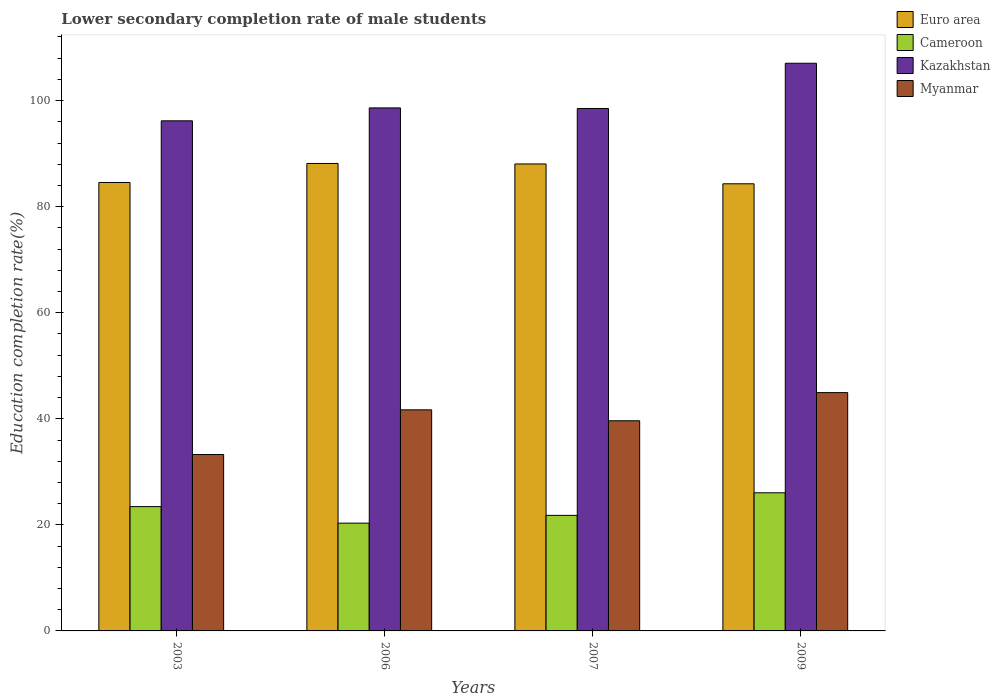How many groups of bars are there?
Provide a succinct answer. 4. Are the number of bars on each tick of the X-axis equal?
Keep it short and to the point. Yes. How many bars are there on the 1st tick from the right?
Ensure brevity in your answer.  4. What is the label of the 4th group of bars from the left?
Your answer should be very brief. 2009. In how many cases, is the number of bars for a given year not equal to the number of legend labels?
Make the answer very short. 0. What is the lower secondary completion rate of male students in Kazakhstan in 2006?
Provide a succinct answer. 98.63. Across all years, what is the maximum lower secondary completion rate of male students in Cameroon?
Provide a short and direct response. 26.05. Across all years, what is the minimum lower secondary completion rate of male students in Cameroon?
Offer a terse response. 20.32. What is the total lower secondary completion rate of male students in Myanmar in the graph?
Make the answer very short. 159.52. What is the difference between the lower secondary completion rate of male students in Myanmar in 2003 and that in 2006?
Your answer should be very brief. -8.43. What is the difference between the lower secondary completion rate of male students in Euro area in 2007 and the lower secondary completion rate of male students in Myanmar in 2003?
Your answer should be very brief. 54.79. What is the average lower secondary completion rate of male students in Myanmar per year?
Offer a terse response. 39.88. In the year 2009, what is the difference between the lower secondary completion rate of male students in Euro area and lower secondary completion rate of male students in Cameroon?
Provide a succinct answer. 58.27. What is the ratio of the lower secondary completion rate of male students in Euro area in 2003 to that in 2009?
Your answer should be very brief. 1. What is the difference between the highest and the second highest lower secondary completion rate of male students in Euro area?
Your response must be concise. 0.09. What is the difference between the highest and the lowest lower secondary completion rate of male students in Euro area?
Provide a short and direct response. 3.83. Is the sum of the lower secondary completion rate of male students in Kazakhstan in 2003 and 2009 greater than the maximum lower secondary completion rate of male students in Euro area across all years?
Your answer should be very brief. Yes. What does the 1st bar from the right in 2007 represents?
Keep it short and to the point. Myanmar. Is it the case that in every year, the sum of the lower secondary completion rate of male students in Kazakhstan and lower secondary completion rate of male students in Cameroon is greater than the lower secondary completion rate of male students in Myanmar?
Your answer should be compact. Yes. How many bars are there?
Your answer should be very brief. 16. How many years are there in the graph?
Your answer should be compact. 4. What is the difference between two consecutive major ticks on the Y-axis?
Provide a short and direct response. 20. Does the graph contain any zero values?
Your response must be concise. No. Does the graph contain grids?
Your answer should be compact. No. How many legend labels are there?
Offer a very short reply. 4. What is the title of the graph?
Ensure brevity in your answer.  Lower secondary completion rate of male students. Does "Tanzania" appear as one of the legend labels in the graph?
Ensure brevity in your answer.  No. What is the label or title of the X-axis?
Offer a very short reply. Years. What is the label or title of the Y-axis?
Ensure brevity in your answer.  Education completion rate(%). What is the Education completion rate(%) of Euro area in 2003?
Offer a terse response. 84.56. What is the Education completion rate(%) in Cameroon in 2003?
Your answer should be compact. 23.44. What is the Education completion rate(%) of Kazakhstan in 2003?
Offer a very short reply. 96.19. What is the Education completion rate(%) in Myanmar in 2003?
Provide a short and direct response. 33.26. What is the Education completion rate(%) of Euro area in 2006?
Provide a succinct answer. 88.15. What is the Education completion rate(%) of Cameroon in 2006?
Offer a terse response. 20.32. What is the Education completion rate(%) in Kazakhstan in 2006?
Offer a terse response. 98.63. What is the Education completion rate(%) of Myanmar in 2006?
Your answer should be very brief. 41.69. What is the Education completion rate(%) in Euro area in 2007?
Give a very brief answer. 88.06. What is the Education completion rate(%) in Cameroon in 2007?
Provide a short and direct response. 21.79. What is the Education completion rate(%) in Kazakhstan in 2007?
Keep it short and to the point. 98.52. What is the Education completion rate(%) of Myanmar in 2007?
Keep it short and to the point. 39.63. What is the Education completion rate(%) of Euro area in 2009?
Provide a succinct answer. 84.32. What is the Education completion rate(%) in Cameroon in 2009?
Provide a short and direct response. 26.05. What is the Education completion rate(%) of Kazakhstan in 2009?
Give a very brief answer. 107.04. What is the Education completion rate(%) of Myanmar in 2009?
Keep it short and to the point. 44.94. Across all years, what is the maximum Education completion rate(%) in Euro area?
Offer a very short reply. 88.15. Across all years, what is the maximum Education completion rate(%) in Cameroon?
Ensure brevity in your answer.  26.05. Across all years, what is the maximum Education completion rate(%) in Kazakhstan?
Provide a short and direct response. 107.04. Across all years, what is the maximum Education completion rate(%) in Myanmar?
Offer a very short reply. 44.94. Across all years, what is the minimum Education completion rate(%) of Euro area?
Make the answer very short. 84.32. Across all years, what is the minimum Education completion rate(%) in Cameroon?
Provide a short and direct response. 20.32. Across all years, what is the minimum Education completion rate(%) of Kazakhstan?
Provide a succinct answer. 96.19. Across all years, what is the minimum Education completion rate(%) in Myanmar?
Offer a very short reply. 33.26. What is the total Education completion rate(%) of Euro area in the graph?
Your response must be concise. 345.08. What is the total Education completion rate(%) in Cameroon in the graph?
Provide a short and direct response. 91.61. What is the total Education completion rate(%) of Kazakhstan in the graph?
Your answer should be very brief. 400.38. What is the total Education completion rate(%) in Myanmar in the graph?
Your response must be concise. 159.52. What is the difference between the Education completion rate(%) in Euro area in 2003 and that in 2006?
Make the answer very short. -3.59. What is the difference between the Education completion rate(%) in Cameroon in 2003 and that in 2006?
Ensure brevity in your answer.  3.12. What is the difference between the Education completion rate(%) in Kazakhstan in 2003 and that in 2006?
Offer a terse response. -2.44. What is the difference between the Education completion rate(%) in Myanmar in 2003 and that in 2006?
Make the answer very short. -8.43. What is the difference between the Education completion rate(%) of Euro area in 2003 and that in 2007?
Offer a very short reply. -3.49. What is the difference between the Education completion rate(%) in Cameroon in 2003 and that in 2007?
Keep it short and to the point. 1.65. What is the difference between the Education completion rate(%) of Kazakhstan in 2003 and that in 2007?
Your answer should be very brief. -2.33. What is the difference between the Education completion rate(%) in Myanmar in 2003 and that in 2007?
Offer a very short reply. -6.36. What is the difference between the Education completion rate(%) in Euro area in 2003 and that in 2009?
Provide a succinct answer. 0.25. What is the difference between the Education completion rate(%) of Cameroon in 2003 and that in 2009?
Offer a terse response. -2.6. What is the difference between the Education completion rate(%) of Kazakhstan in 2003 and that in 2009?
Provide a succinct answer. -10.85. What is the difference between the Education completion rate(%) of Myanmar in 2003 and that in 2009?
Give a very brief answer. -11.67. What is the difference between the Education completion rate(%) in Euro area in 2006 and that in 2007?
Keep it short and to the point. 0.09. What is the difference between the Education completion rate(%) in Cameroon in 2006 and that in 2007?
Offer a terse response. -1.47. What is the difference between the Education completion rate(%) of Kazakhstan in 2006 and that in 2007?
Your response must be concise. 0.11. What is the difference between the Education completion rate(%) in Myanmar in 2006 and that in 2007?
Keep it short and to the point. 2.06. What is the difference between the Education completion rate(%) in Euro area in 2006 and that in 2009?
Offer a terse response. 3.83. What is the difference between the Education completion rate(%) of Cameroon in 2006 and that in 2009?
Your answer should be compact. -5.72. What is the difference between the Education completion rate(%) in Kazakhstan in 2006 and that in 2009?
Ensure brevity in your answer.  -8.42. What is the difference between the Education completion rate(%) of Myanmar in 2006 and that in 2009?
Give a very brief answer. -3.25. What is the difference between the Education completion rate(%) in Euro area in 2007 and that in 2009?
Offer a terse response. 3.74. What is the difference between the Education completion rate(%) of Cameroon in 2007 and that in 2009?
Your answer should be very brief. -4.26. What is the difference between the Education completion rate(%) of Kazakhstan in 2007 and that in 2009?
Offer a terse response. -8.53. What is the difference between the Education completion rate(%) in Myanmar in 2007 and that in 2009?
Offer a terse response. -5.31. What is the difference between the Education completion rate(%) in Euro area in 2003 and the Education completion rate(%) in Cameroon in 2006?
Your answer should be very brief. 64.24. What is the difference between the Education completion rate(%) in Euro area in 2003 and the Education completion rate(%) in Kazakhstan in 2006?
Keep it short and to the point. -14.07. What is the difference between the Education completion rate(%) in Euro area in 2003 and the Education completion rate(%) in Myanmar in 2006?
Give a very brief answer. 42.87. What is the difference between the Education completion rate(%) of Cameroon in 2003 and the Education completion rate(%) of Kazakhstan in 2006?
Keep it short and to the point. -75.18. What is the difference between the Education completion rate(%) in Cameroon in 2003 and the Education completion rate(%) in Myanmar in 2006?
Give a very brief answer. -18.25. What is the difference between the Education completion rate(%) in Kazakhstan in 2003 and the Education completion rate(%) in Myanmar in 2006?
Ensure brevity in your answer.  54.5. What is the difference between the Education completion rate(%) of Euro area in 2003 and the Education completion rate(%) of Cameroon in 2007?
Ensure brevity in your answer.  62.77. What is the difference between the Education completion rate(%) in Euro area in 2003 and the Education completion rate(%) in Kazakhstan in 2007?
Ensure brevity in your answer.  -13.95. What is the difference between the Education completion rate(%) of Euro area in 2003 and the Education completion rate(%) of Myanmar in 2007?
Make the answer very short. 44.93. What is the difference between the Education completion rate(%) of Cameroon in 2003 and the Education completion rate(%) of Kazakhstan in 2007?
Provide a short and direct response. -75.07. What is the difference between the Education completion rate(%) in Cameroon in 2003 and the Education completion rate(%) in Myanmar in 2007?
Provide a short and direct response. -16.18. What is the difference between the Education completion rate(%) of Kazakhstan in 2003 and the Education completion rate(%) of Myanmar in 2007?
Your response must be concise. 56.56. What is the difference between the Education completion rate(%) of Euro area in 2003 and the Education completion rate(%) of Cameroon in 2009?
Your response must be concise. 58.51. What is the difference between the Education completion rate(%) of Euro area in 2003 and the Education completion rate(%) of Kazakhstan in 2009?
Ensure brevity in your answer.  -22.48. What is the difference between the Education completion rate(%) in Euro area in 2003 and the Education completion rate(%) in Myanmar in 2009?
Offer a very short reply. 39.63. What is the difference between the Education completion rate(%) of Cameroon in 2003 and the Education completion rate(%) of Kazakhstan in 2009?
Make the answer very short. -83.6. What is the difference between the Education completion rate(%) of Cameroon in 2003 and the Education completion rate(%) of Myanmar in 2009?
Keep it short and to the point. -21.49. What is the difference between the Education completion rate(%) in Kazakhstan in 2003 and the Education completion rate(%) in Myanmar in 2009?
Keep it short and to the point. 51.25. What is the difference between the Education completion rate(%) of Euro area in 2006 and the Education completion rate(%) of Cameroon in 2007?
Make the answer very short. 66.36. What is the difference between the Education completion rate(%) in Euro area in 2006 and the Education completion rate(%) in Kazakhstan in 2007?
Give a very brief answer. -10.37. What is the difference between the Education completion rate(%) in Euro area in 2006 and the Education completion rate(%) in Myanmar in 2007?
Provide a short and direct response. 48.52. What is the difference between the Education completion rate(%) in Cameroon in 2006 and the Education completion rate(%) in Kazakhstan in 2007?
Your answer should be compact. -78.19. What is the difference between the Education completion rate(%) of Cameroon in 2006 and the Education completion rate(%) of Myanmar in 2007?
Your answer should be very brief. -19.3. What is the difference between the Education completion rate(%) in Kazakhstan in 2006 and the Education completion rate(%) in Myanmar in 2007?
Offer a terse response. 59. What is the difference between the Education completion rate(%) of Euro area in 2006 and the Education completion rate(%) of Cameroon in 2009?
Offer a very short reply. 62.1. What is the difference between the Education completion rate(%) in Euro area in 2006 and the Education completion rate(%) in Kazakhstan in 2009?
Provide a short and direct response. -18.9. What is the difference between the Education completion rate(%) of Euro area in 2006 and the Education completion rate(%) of Myanmar in 2009?
Keep it short and to the point. 43.21. What is the difference between the Education completion rate(%) in Cameroon in 2006 and the Education completion rate(%) in Kazakhstan in 2009?
Your response must be concise. -86.72. What is the difference between the Education completion rate(%) of Cameroon in 2006 and the Education completion rate(%) of Myanmar in 2009?
Ensure brevity in your answer.  -24.61. What is the difference between the Education completion rate(%) in Kazakhstan in 2006 and the Education completion rate(%) in Myanmar in 2009?
Offer a terse response. 53.69. What is the difference between the Education completion rate(%) of Euro area in 2007 and the Education completion rate(%) of Cameroon in 2009?
Offer a terse response. 62.01. What is the difference between the Education completion rate(%) of Euro area in 2007 and the Education completion rate(%) of Kazakhstan in 2009?
Ensure brevity in your answer.  -18.99. What is the difference between the Education completion rate(%) in Euro area in 2007 and the Education completion rate(%) in Myanmar in 2009?
Give a very brief answer. 43.12. What is the difference between the Education completion rate(%) in Cameroon in 2007 and the Education completion rate(%) in Kazakhstan in 2009?
Your answer should be compact. -85.25. What is the difference between the Education completion rate(%) of Cameroon in 2007 and the Education completion rate(%) of Myanmar in 2009?
Give a very brief answer. -23.14. What is the difference between the Education completion rate(%) in Kazakhstan in 2007 and the Education completion rate(%) in Myanmar in 2009?
Your answer should be very brief. 53.58. What is the average Education completion rate(%) of Euro area per year?
Ensure brevity in your answer.  86.27. What is the average Education completion rate(%) of Cameroon per year?
Offer a very short reply. 22.9. What is the average Education completion rate(%) in Kazakhstan per year?
Offer a very short reply. 100.09. What is the average Education completion rate(%) in Myanmar per year?
Keep it short and to the point. 39.88. In the year 2003, what is the difference between the Education completion rate(%) of Euro area and Education completion rate(%) of Cameroon?
Make the answer very short. 61.12. In the year 2003, what is the difference between the Education completion rate(%) in Euro area and Education completion rate(%) in Kazakhstan?
Keep it short and to the point. -11.63. In the year 2003, what is the difference between the Education completion rate(%) in Euro area and Education completion rate(%) in Myanmar?
Offer a terse response. 51.3. In the year 2003, what is the difference between the Education completion rate(%) of Cameroon and Education completion rate(%) of Kazakhstan?
Give a very brief answer. -72.75. In the year 2003, what is the difference between the Education completion rate(%) in Cameroon and Education completion rate(%) in Myanmar?
Your response must be concise. -9.82. In the year 2003, what is the difference between the Education completion rate(%) of Kazakhstan and Education completion rate(%) of Myanmar?
Offer a terse response. 62.93. In the year 2006, what is the difference between the Education completion rate(%) in Euro area and Education completion rate(%) in Cameroon?
Your response must be concise. 67.82. In the year 2006, what is the difference between the Education completion rate(%) in Euro area and Education completion rate(%) in Kazakhstan?
Provide a succinct answer. -10.48. In the year 2006, what is the difference between the Education completion rate(%) of Euro area and Education completion rate(%) of Myanmar?
Your answer should be compact. 46.46. In the year 2006, what is the difference between the Education completion rate(%) in Cameroon and Education completion rate(%) in Kazakhstan?
Your answer should be very brief. -78.3. In the year 2006, what is the difference between the Education completion rate(%) in Cameroon and Education completion rate(%) in Myanmar?
Provide a succinct answer. -21.37. In the year 2006, what is the difference between the Education completion rate(%) of Kazakhstan and Education completion rate(%) of Myanmar?
Your response must be concise. 56.94. In the year 2007, what is the difference between the Education completion rate(%) of Euro area and Education completion rate(%) of Cameroon?
Provide a succinct answer. 66.27. In the year 2007, what is the difference between the Education completion rate(%) in Euro area and Education completion rate(%) in Kazakhstan?
Make the answer very short. -10.46. In the year 2007, what is the difference between the Education completion rate(%) in Euro area and Education completion rate(%) in Myanmar?
Provide a short and direct response. 48.43. In the year 2007, what is the difference between the Education completion rate(%) in Cameroon and Education completion rate(%) in Kazakhstan?
Keep it short and to the point. -76.73. In the year 2007, what is the difference between the Education completion rate(%) in Cameroon and Education completion rate(%) in Myanmar?
Give a very brief answer. -17.84. In the year 2007, what is the difference between the Education completion rate(%) in Kazakhstan and Education completion rate(%) in Myanmar?
Make the answer very short. 58.89. In the year 2009, what is the difference between the Education completion rate(%) of Euro area and Education completion rate(%) of Cameroon?
Offer a terse response. 58.27. In the year 2009, what is the difference between the Education completion rate(%) of Euro area and Education completion rate(%) of Kazakhstan?
Keep it short and to the point. -22.73. In the year 2009, what is the difference between the Education completion rate(%) in Euro area and Education completion rate(%) in Myanmar?
Provide a succinct answer. 39.38. In the year 2009, what is the difference between the Education completion rate(%) in Cameroon and Education completion rate(%) in Kazakhstan?
Your answer should be compact. -81. In the year 2009, what is the difference between the Education completion rate(%) of Cameroon and Education completion rate(%) of Myanmar?
Give a very brief answer. -18.89. In the year 2009, what is the difference between the Education completion rate(%) of Kazakhstan and Education completion rate(%) of Myanmar?
Provide a short and direct response. 62.11. What is the ratio of the Education completion rate(%) of Euro area in 2003 to that in 2006?
Offer a terse response. 0.96. What is the ratio of the Education completion rate(%) in Cameroon in 2003 to that in 2006?
Ensure brevity in your answer.  1.15. What is the ratio of the Education completion rate(%) of Kazakhstan in 2003 to that in 2006?
Provide a succinct answer. 0.98. What is the ratio of the Education completion rate(%) in Myanmar in 2003 to that in 2006?
Your response must be concise. 0.8. What is the ratio of the Education completion rate(%) of Euro area in 2003 to that in 2007?
Your response must be concise. 0.96. What is the ratio of the Education completion rate(%) in Cameroon in 2003 to that in 2007?
Your answer should be very brief. 1.08. What is the ratio of the Education completion rate(%) of Kazakhstan in 2003 to that in 2007?
Your answer should be very brief. 0.98. What is the ratio of the Education completion rate(%) of Myanmar in 2003 to that in 2007?
Give a very brief answer. 0.84. What is the ratio of the Education completion rate(%) in Cameroon in 2003 to that in 2009?
Provide a succinct answer. 0.9. What is the ratio of the Education completion rate(%) in Kazakhstan in 2003 to that in 2009?
Provide a short and direct response. 0.9. What is the ratio of the Education completion rate(%) of Myanmar in 2003 to that in 2009?
Provide a short and direct response. 0.74. What is the ratio of the Education completion rate(%) of Cameroon in 2006 to that in 2007?
Make the answer very short. 0.93. What is the ratio of the Education completion rate(%) of Kazakhstan in 2006 to that in 2007?
Offer a terse response. 1. What is the ratio of the Education completion rate(%) of Myanmar in 2006 to that in 2007?
Provide a succinct answer. 1.05. What is the ratio of the Education completion rate(%) in Euro area in 2006 to that in 2009?
Offer a terse response. 1.05. What is the ratio of the Education completion rate(%) in Cameroon in 2006 to that in 2009?
Ensure brevity in your answer.  0.78. What is the ratio of the Education completion rate(%) of Kazakhstan in 2006 to that in 2009?
Offer a terse response. 0.92. What is the ratio of the Education completion rate(%) of Myanmar in 2006 to that in 2009?
Offer a very short reply. 0.93. What is the ratio of the Education completion rate(%) of Euro area in 2007 to that in 2009?
Make the answer very short. 1.04. What is the ratio of the Education completion rate(%) in Cameroon in 2007 to that in 2009?
Keep it short and to the point. 0.84. What is the ratio of the Education completion rate(%) in Kazakhstan in 2007 to that in 2009?
Offer a very short reply. 0.92. What is the ratio of the Education completion rate(%) in Myanmar in 2007 to that in 2009?
Offer a very short reply. 0.88. What is the difference between the highest and the second highest Education completion rate(%) in Euro area?
Your response must be concise. 0.09. What is the difference between the highest and the second highest Education completion rate(%) in Cameroon?
Your response must be concise. 2.6. What is the difference between the highest and the second highest Education completion rate(%) of Kazakhstan?
Make the answer very short. 8.42. What is the difference between the highest and the second highest Education completion rate(%) in Myanmar?
Make the answer very short. 3.25. What is the difference between the highest and the lowest Education completion rate(%) in Euro area?
Your response must be concise. 3.83. What is the difference between the highest and the lowest Education completion rate(%) of Cameroon?
Offer a terse response. 5.72. What is the difference between the highest and the lowest Education completion rate(%) in Kazakhstan?
Provide a succinct answer. 10.85. What is the difference between the highest and the lowest Education completion rate(%) in Myanmar?
Offer a very short reply. 11.67. 